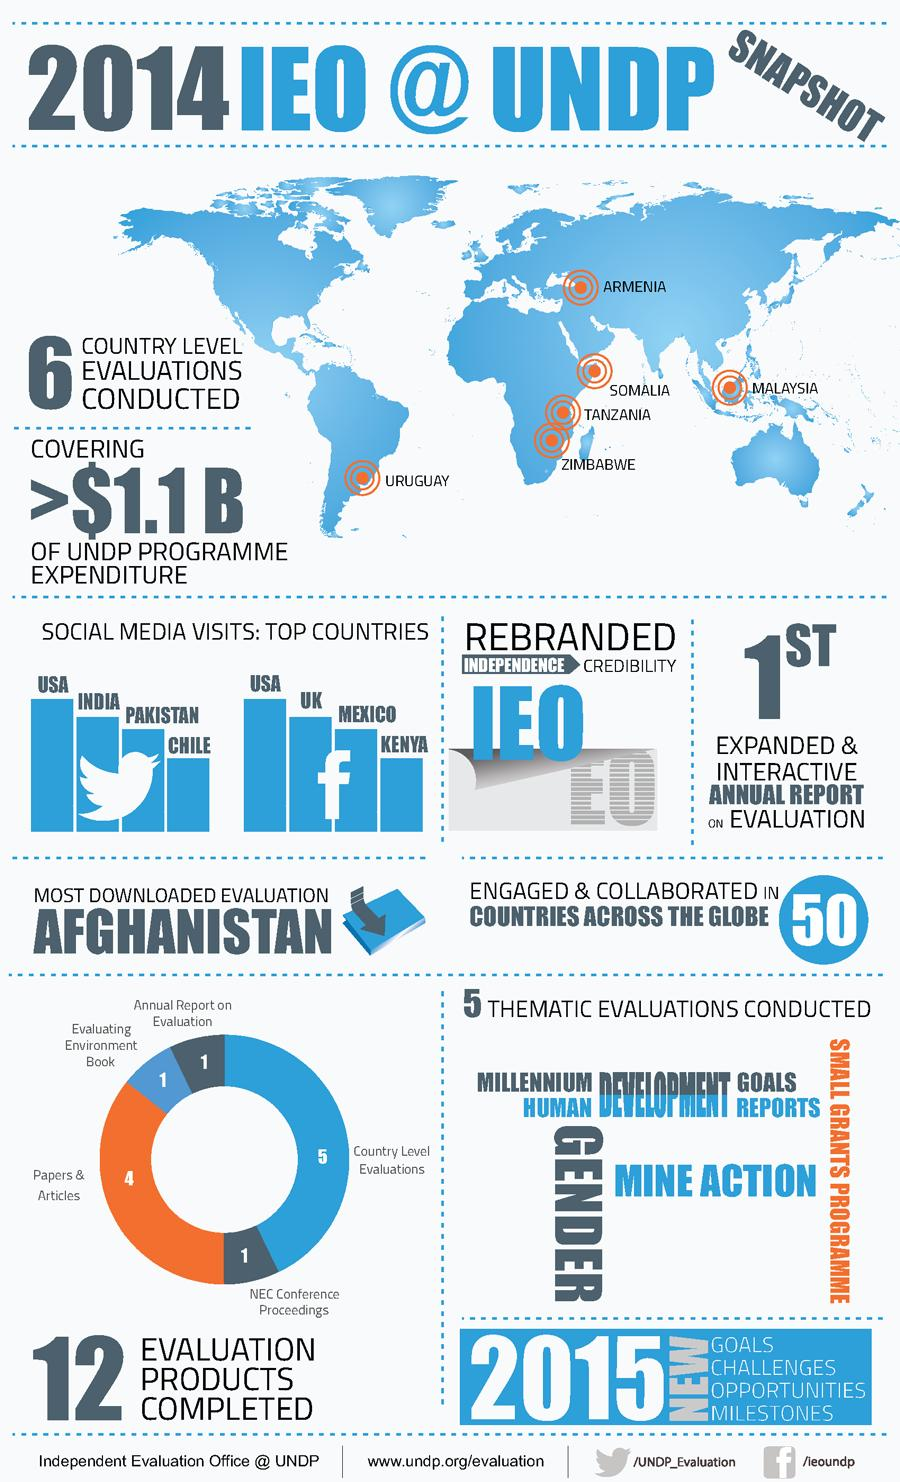Highlight a few significant elements in this photo. In 2014, the United States of America had the highest number of Facebook users among all countries. In 2014, India had the second highest number of Twitter users. In 2014, the United Kingdom had the second highest number of Facebook users among all countries. 